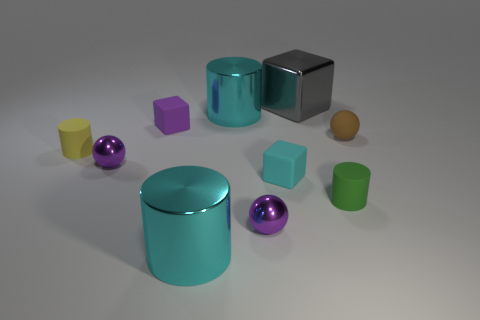Subtract 1 cylinders. How many cylinders are left? 3 Subtract all blue spheres. Subtract all brown cylinders. How many spheres are left? 3 Subtract all cylinders. How many objects are left? 6 Subtract all small things. Subtract all purple blocks. How many objects are left? 2 Add 4 big cyan cylinders. How many big cyan cylinders are left? 6 Add 4 cyan rubber cubes. How many cyan rubber cubes exist? 5 Subtract 0 purple cylinders. How many objects are left? 10 